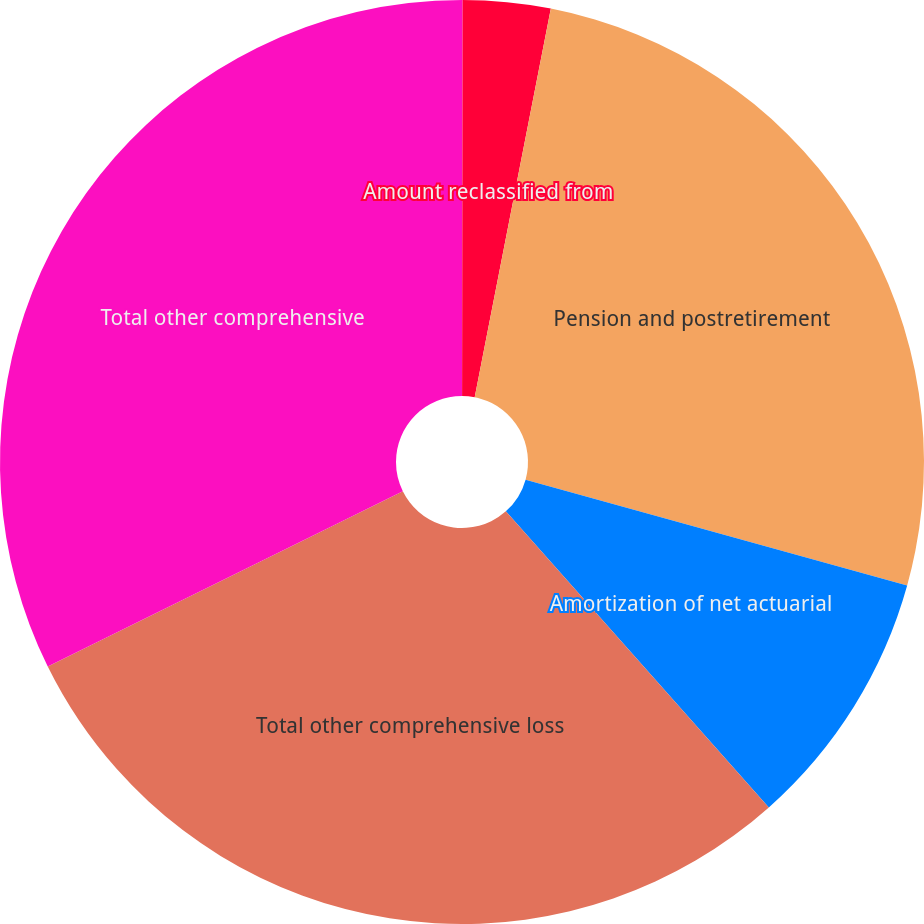Convert chart to OTSL. <chart><loc_0><loc_0><loc_500><loc_500><pie_chart><fcel>Unrealized loss on<fcel>Amount reclassified from<fcel>Pension and postretirement<fcel>Amortization of net actuarial<fcel>Total other comprehensive loss<fcel>Total other comprehensive<nl><fcel>0.02%<fcel>3.06%<fcel>26.23%<fcel>9.13%<fcel>29.26%<fcel>32.3%<nl></chart> 